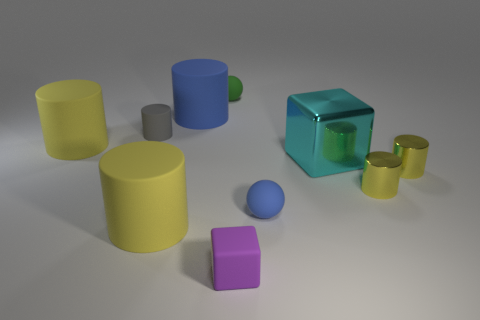Which object appears the most reflective, and how could that affect the perception of its surroundings? The object with the highest reflectivity is the teal cube. Its reflective surface acts like a mirror, providing inverted images of other objects and altering our perception of depth and space within the image. 